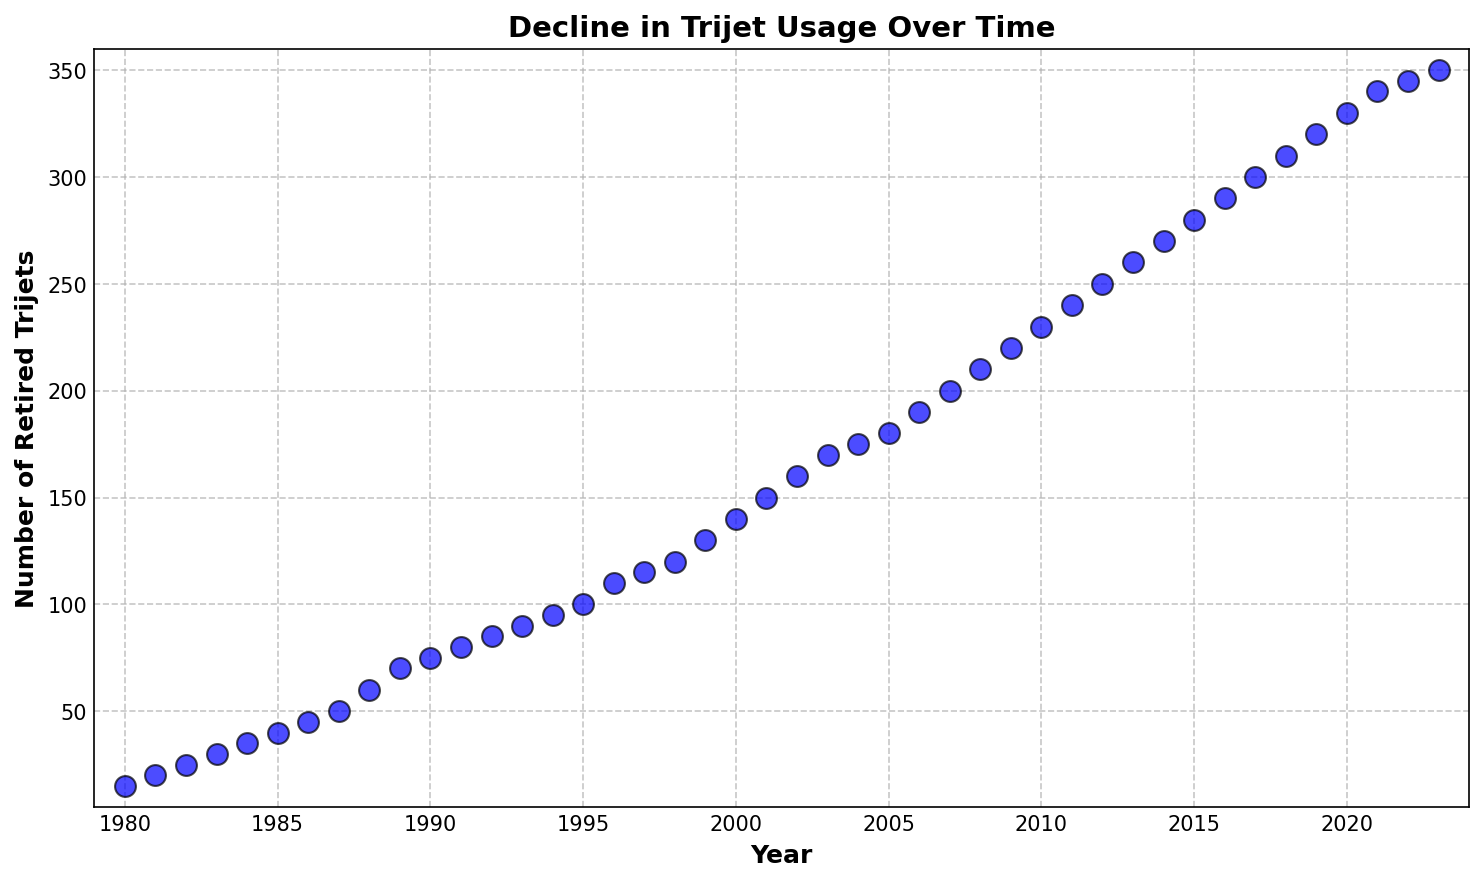What's the trend in the number of retired trijets over the years? The plot clearly shows an increasing trend in the number of retired trijets from 1980 to 2023. By visually observing the slope of the scatter plot, it can be seen that the number has increased steadily over time.
Answer: Increasing Which year had the highest number of retired trijets? By looking at the plot, the year with the highest point on the y-axis represents the highest number of retired trijets. The highest point on the plot corresponds to the year 2023.
Answer: 2023 Around which year did the number of retired trijets start to exceed 200? Identifying where the y-axis value crosses 200 and then tracing it back to the x-axis, we can see that this occurs around 2007.
Answer: 2007 What is the difference in the number of retired trijets between the years 1985 and 2000? By observing the values on the y-axis for 1985 (40 trijets) and 2000 (140 trijets), the difference is calculated as 140 - 40.
Answer: 100 How many trijets were retired in the year 1990? By directly referring to the scatter point corresponding to the year 1990, we can see that 75 trijets were retired.
Answer: 75 Approximately how much did the number of retired trijets increase annually between 1980 and 2023? To calculate the approximate annual increase, find the total change in retired trijets, which is 350 - 15 = 335, and divide it by the number of years, 2023 - 1980 = 43. So, 335 / 43 ≈ 7.79 trijets per year.
Answer: Approximately 7.79 Which decade saw the most significant increase in the number of retired trijets? Comparing the slope of the plot in different decades, the most significant increase appears to be from 2000 to 2010 where the slope is steepest.
Answer: 2000s Around what year did the rate of retiring trijets accelerate notably? Observing the plot, there is a more noticeable steepening of the slope around the mid-1980s.
Answer: Mid-1980s 